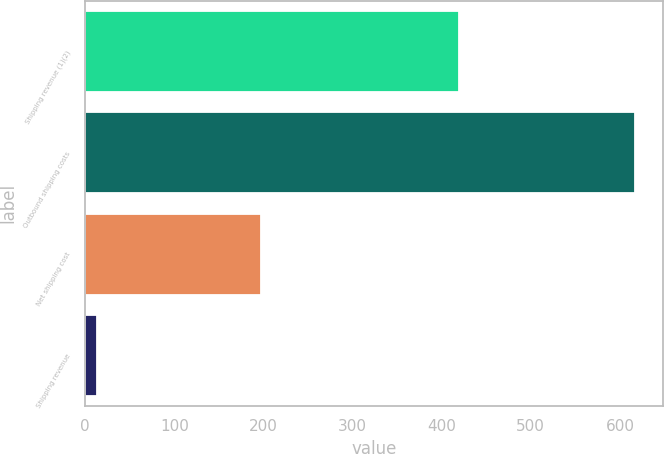<chart> <loc_0><loc_0><loc_500><loc_500><bar_chart><fcel>Shipping revenue (1)(2)<fcel>Outbound shipping costs<fcel>Net shipping cost<fcel>Shipping revenue<nl><fcel>420<fcel>617<fcel>197<fcel>13<nl></chart> 